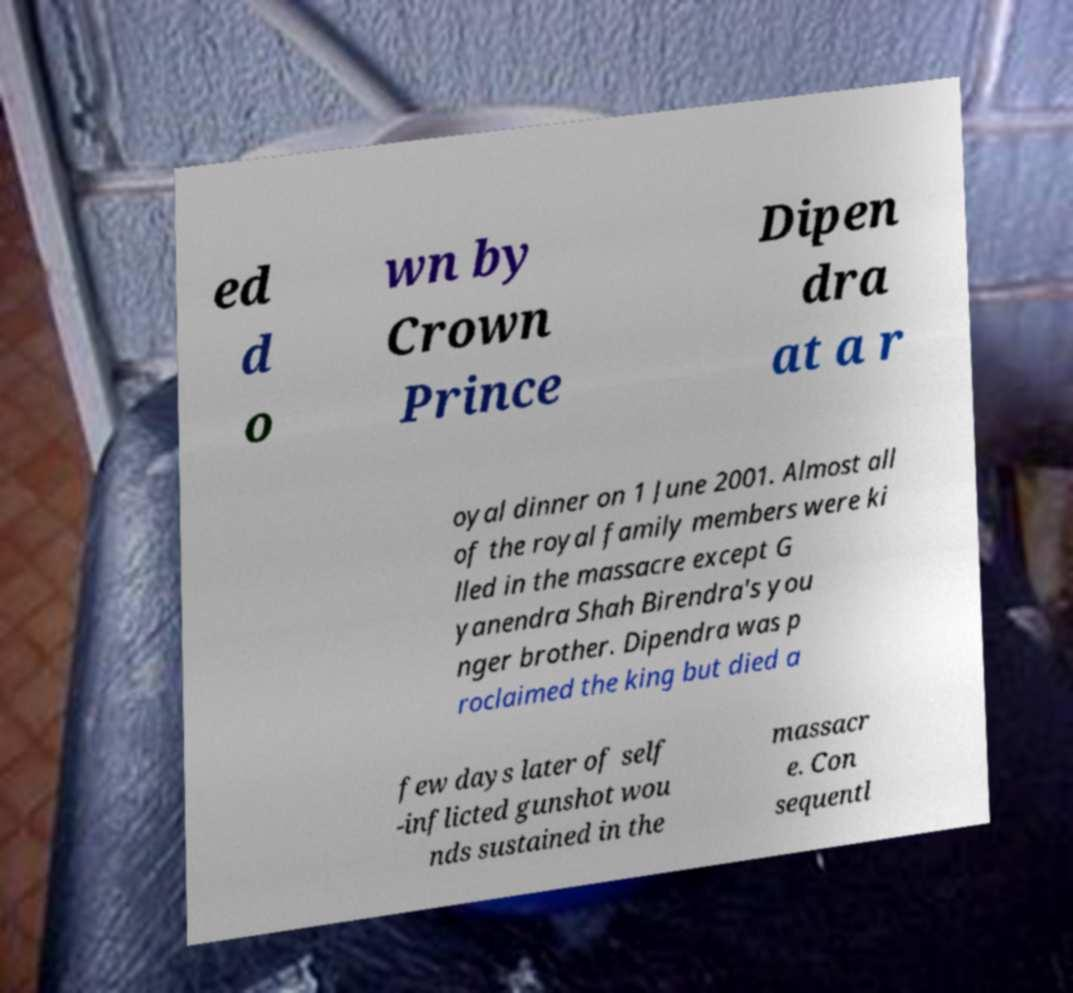Please read and relay the text visible in this image. What does it say? ed d o wn by Crown Prince Dipen dra at a r oyal dinner on 1 June 2001. Almost all of the royal family members were ki lled in the massacre except G yanendra Shah Birendra's you nger brother. Dipendra was p roclaimed the king but died a few days later of self -inflicted gunshot wou nds sustained in the massacr e. Con sequentl 